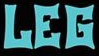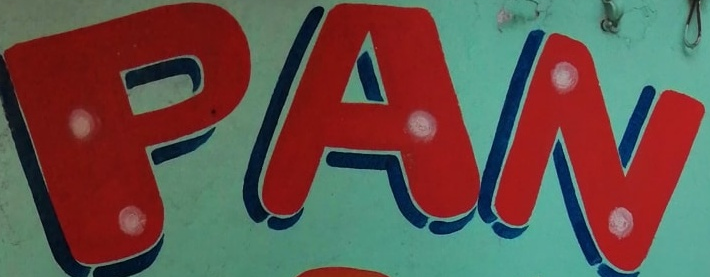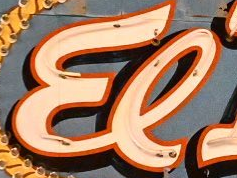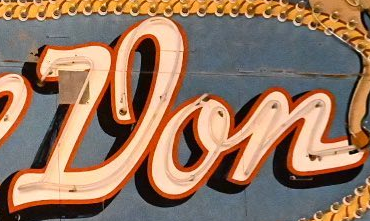What words can you see in these images in sequence, separated by a semicolon? LEG; PAN; El; Don 